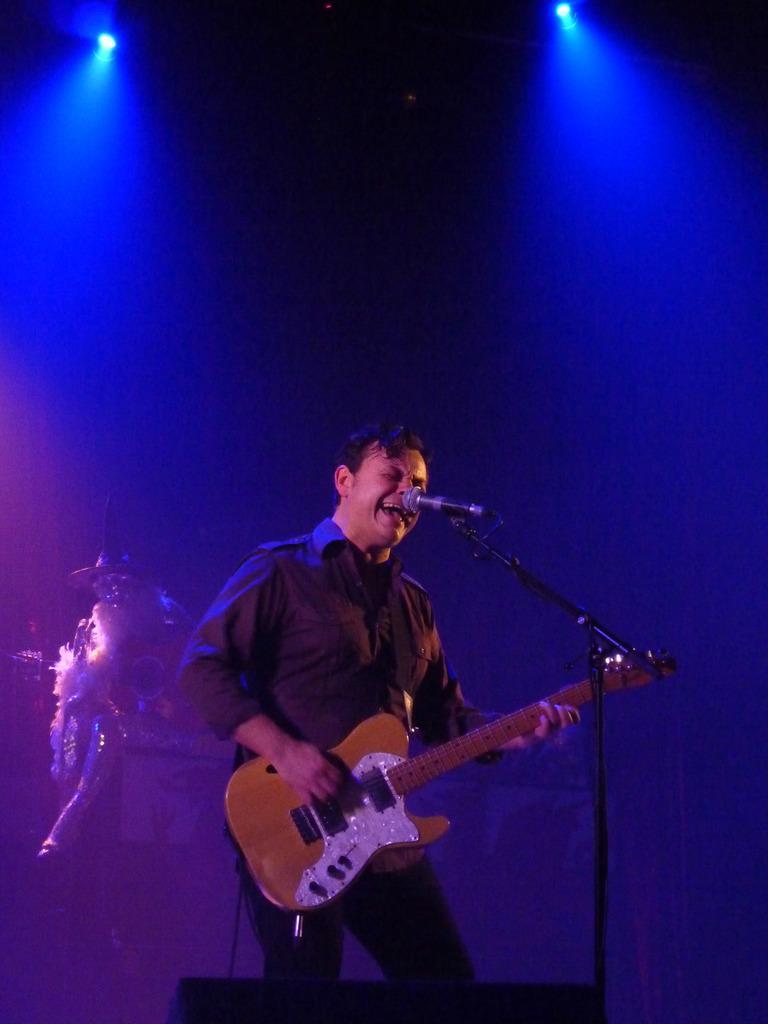Describe this image in one or two sentences. In this image we can see a person standing and holding a guitar in his hands, mic, mic stand, cable, electric lights and a person's shadow. 